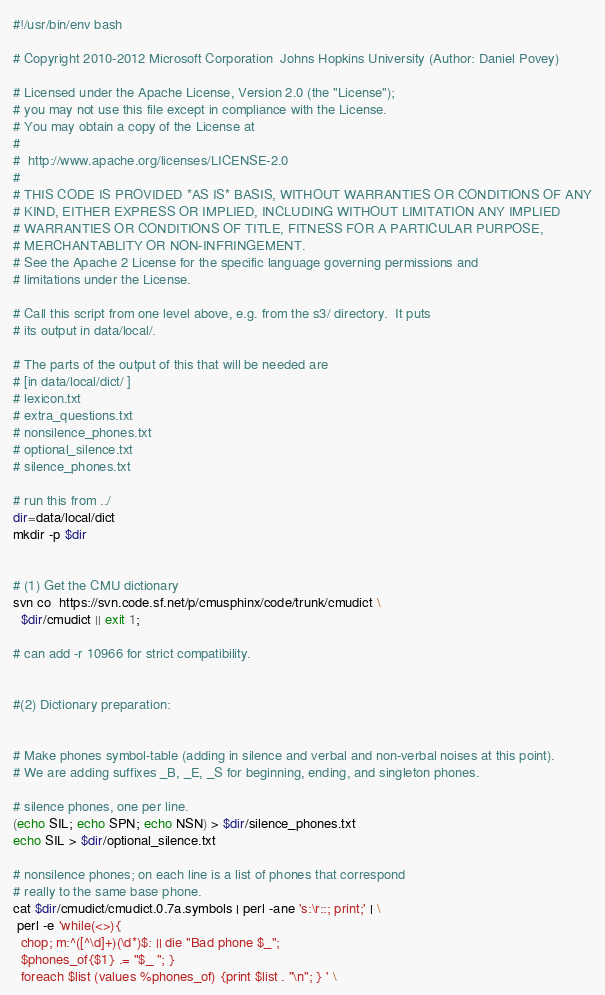<code> <loc_0><loc_0><loc_500><loc_500><_Bash_>#!/usr/bin/env bash

# Copyright 2010-2012 Microsoft Corporation  Johns Hopkins University (Author: Daniel Povey)

# Licensed under the Apache License, Version 2.0 (the "License");
# you may not use this file except in compliance with the License.
# You may obtain a copy of the License at
#
#  http://www.apache.org/licenses/LICENSE-2.0
#
# THIS CODE IS PROVIDED *AS IS* BASIS, WITHOUT WARRANTIES OR CONDITIONS OF ANY
# KIND, EITHER EXPRESS OR IMPLIED, INCLUDING WITHOUT LIMITATION ANY IMPLIED
# WARRANTIES OR CONDITIONS OF TITLE, FITNESS FOR A PARTICULAR PURPOSE,
# MERCHANTABLITY OR NON-INFRINGEMENT.
# See the Apache 2 License for the specific language governing permissions and
# limitations under the License.

# Call this script from one level above, e.g. from the s3/ directory.  It puts
# its output in data/local/.

# The parts of the output of this that will be needed are
# [in data/local/dict/ ]
# lexicon.txt
# extra_questions.txt
# nonsilence_phones.txt
# optional_silence.txt
# silence_phones.txt

# run this from ../
dir=data/local/dict
mkdir -p $dir


# (1) Get the CMU dictionary
svn co  https://svn.code.sf.net/p/cmusphinx/code/trunk/cmudict \
  $dir/cmudict || exit 1;

# can add -r 10966 for strict compatibility.


#(2) Dictionary preparation:


# Make phones symbol-table (adding in silence and verbal and non-verbal noises at this point).
# We are adding suffixes _B, _E, _S for beginning, ending, and singleton phones.

# silence phones, one per line.
(echo SIL; echo SPN; echo NSN) > $dir/silence_phones.txt
echo SIL > $dir/optional_silence.txt

# nonsilence phones; on each line is a list of phones that correspond
# really to the same base phone.
cat $dir/cmudict/cmudict.0.7a.symbols | perl -ane 's:\r::; print;' | \
 perl -e 'while(<>){
  chop; m:^([^\d]+)(\d*)$: || die "Bad phone $_"; 
  $phones_of{$1} .= "$_ "; }
  foreach $list (values %phones_of) {print $list . "\n"; } ' \</code> 